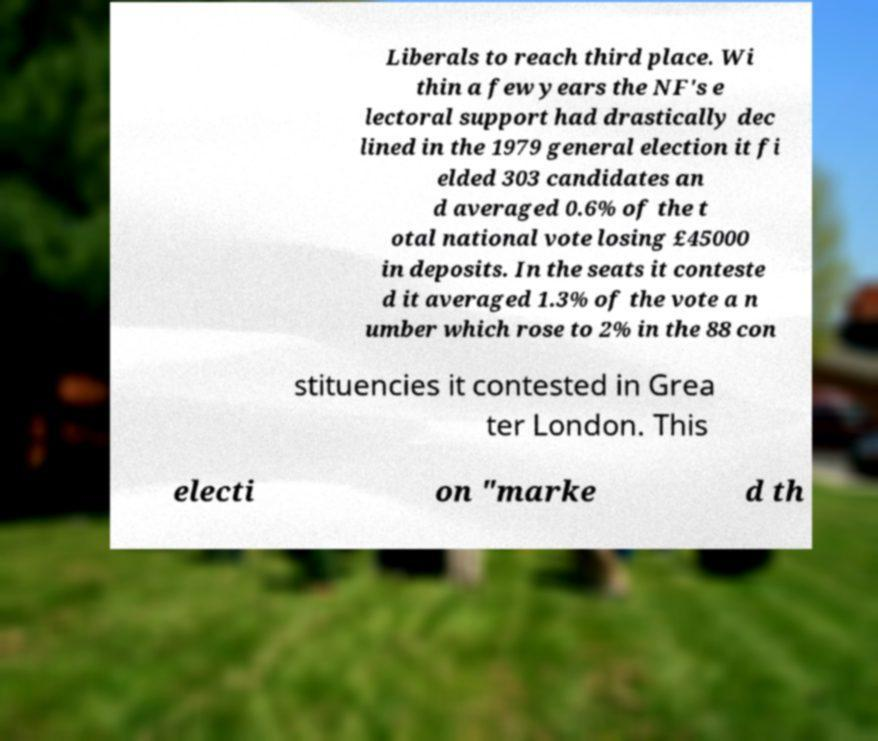Please identify and transcribe the text found in this image. Liberals to reach third place. Wi thin a few years the NF's e lectoral support had drastically dec lined in the 1979 general election it fi elded 303 candidates an d averaged 0.6% of the t otal national vote losing £45000 in deposits. In the seats it conteste d it averaged 1.3% of the vote a n umber which rose to 2% in the 88 con stituencies it contested in Grea ter London. This electi on "marke d th 